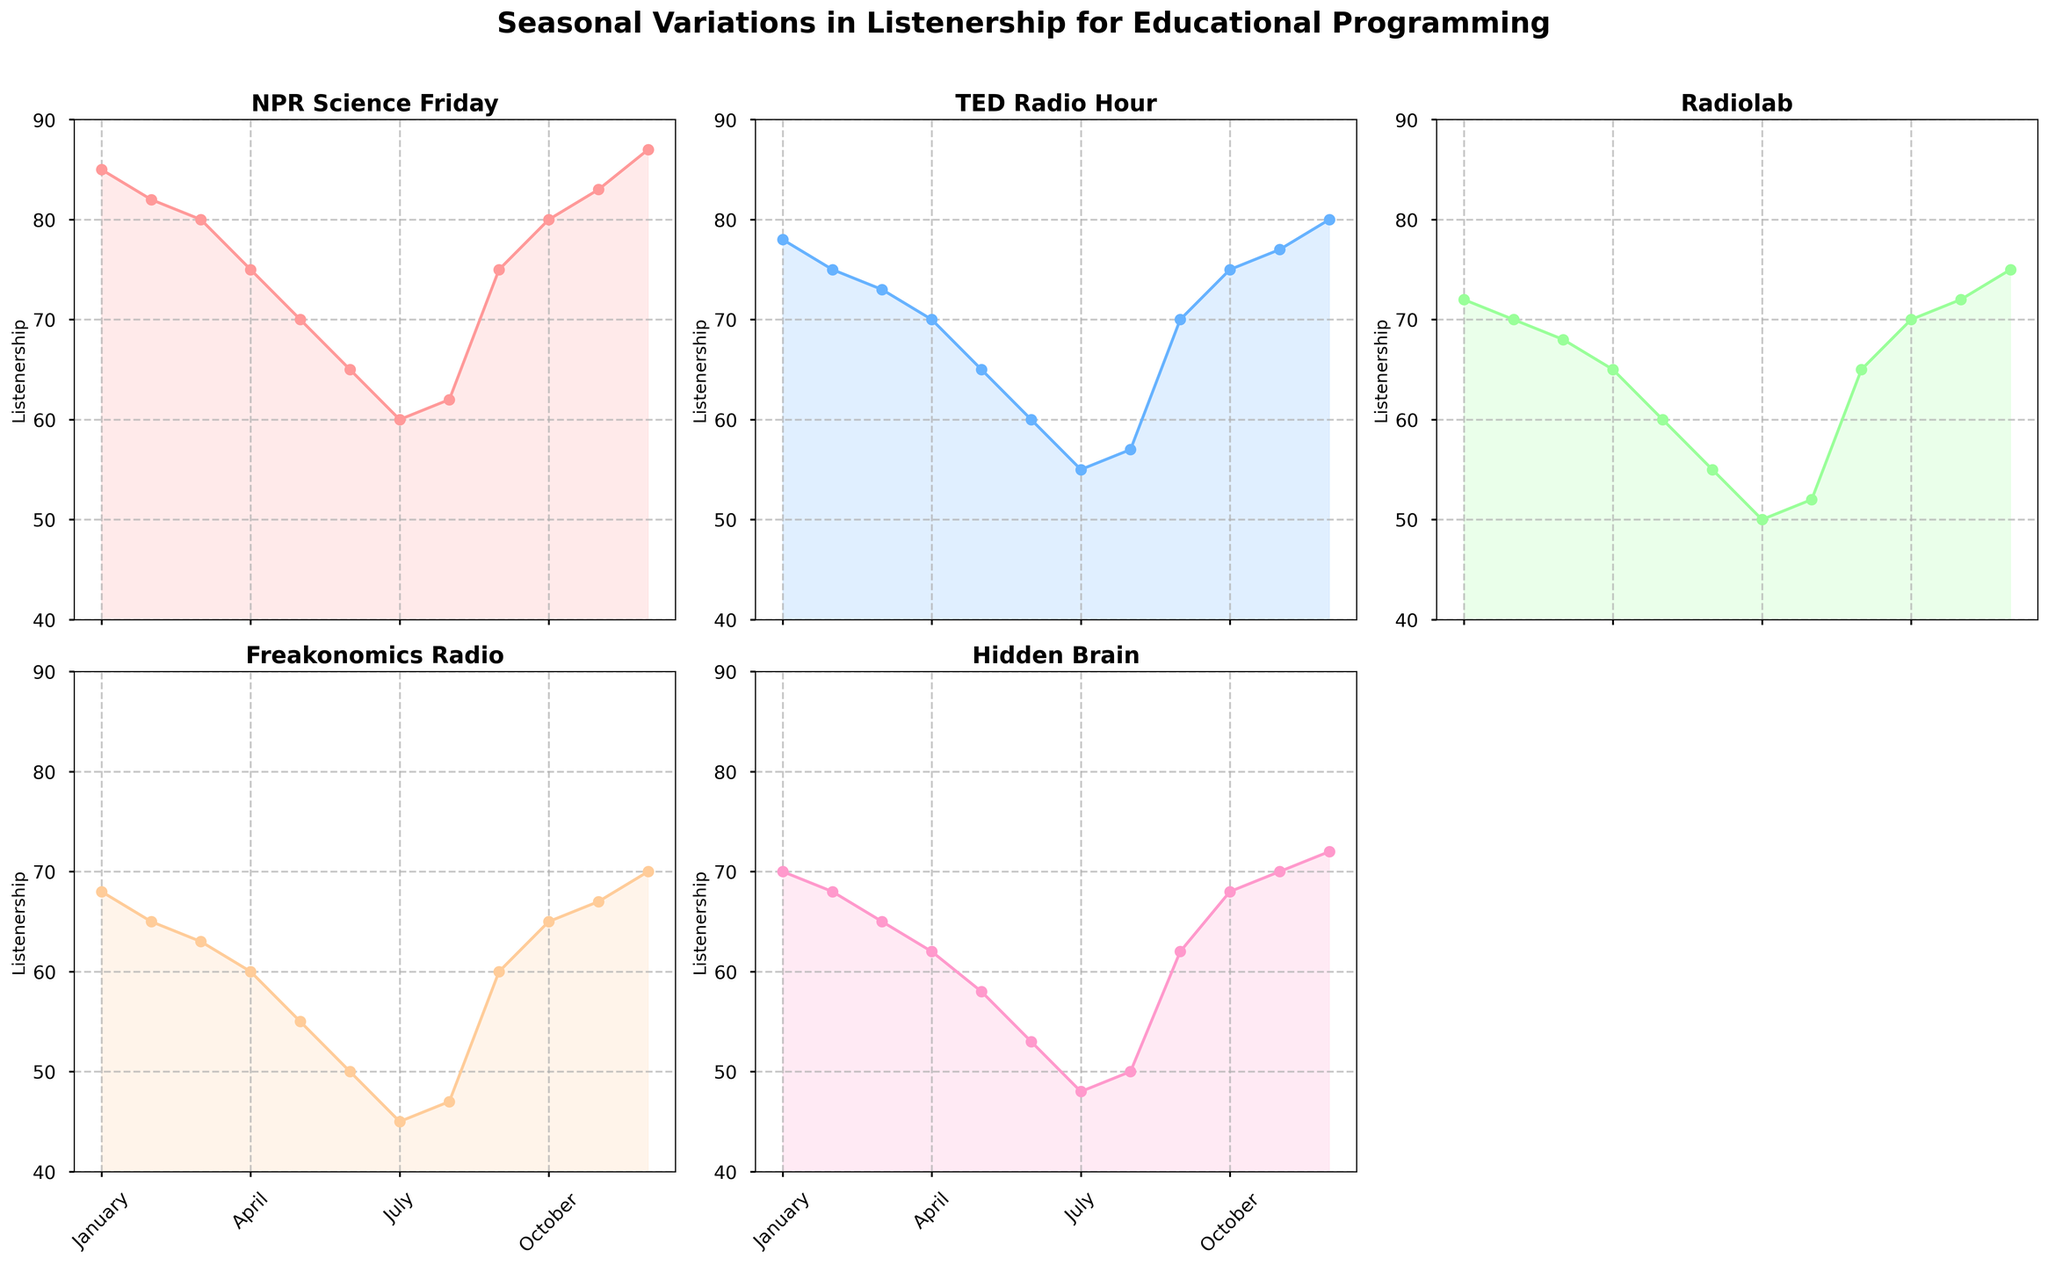Which program shows the highest listenership in December? December has the highest data points for all programs. By looking at the subplots, NPR Science Friday has the highest value in December.
Answer: NPR Science Friday What's the range of listenership values for Radiolab throughout the year? The highest value for Radiolab is in December at 75, and the lowest value is in July at 50. The range is the highest value minus the lowest value, which is 75 - 50 = 25.
Answer: 25 Which months have the lowest listenership for TED Radio Hour? By looking at the TED Radio Hour subplot, the lowest value is in July.
Answer: July What is the sum of listenership values for Freakonomics Radio in March and April? The value in March is 63 and in April is 60. Summing these values gives 63 + 60 = 123.
Answer: 123 What is the average listenership for Hidden Brain during the summer months (June, July, August)? The values are 53 for June, 48 for July, and 50 for August. Summing these gives 53 + 48 + 50 = 151. Dividing by 3 (the number of months) gives an average of 151/3 ≈ 50.33.
Answer: 50.33 In which month does NPR Science Friday see a peak listenership? The highest value for NPR Science Friday is evident in the month of December.
Answer: December Which program shows the least variation in listenership throughout the year? Variation can be observed by the range of values. Hidden Brain has the smallest range from 48 in July to 72 in December, resulting in a range of 24. Comparing ranges across all programs, Hidden Brain indeed has the least variation.
Answer: Hidden Brain During which month are all programs showing the lowest listenership? By comparing all the subplots, July shows the lowest listenership for most programs. Therefore, July is the month where listenership is low across all.
Answer: July 